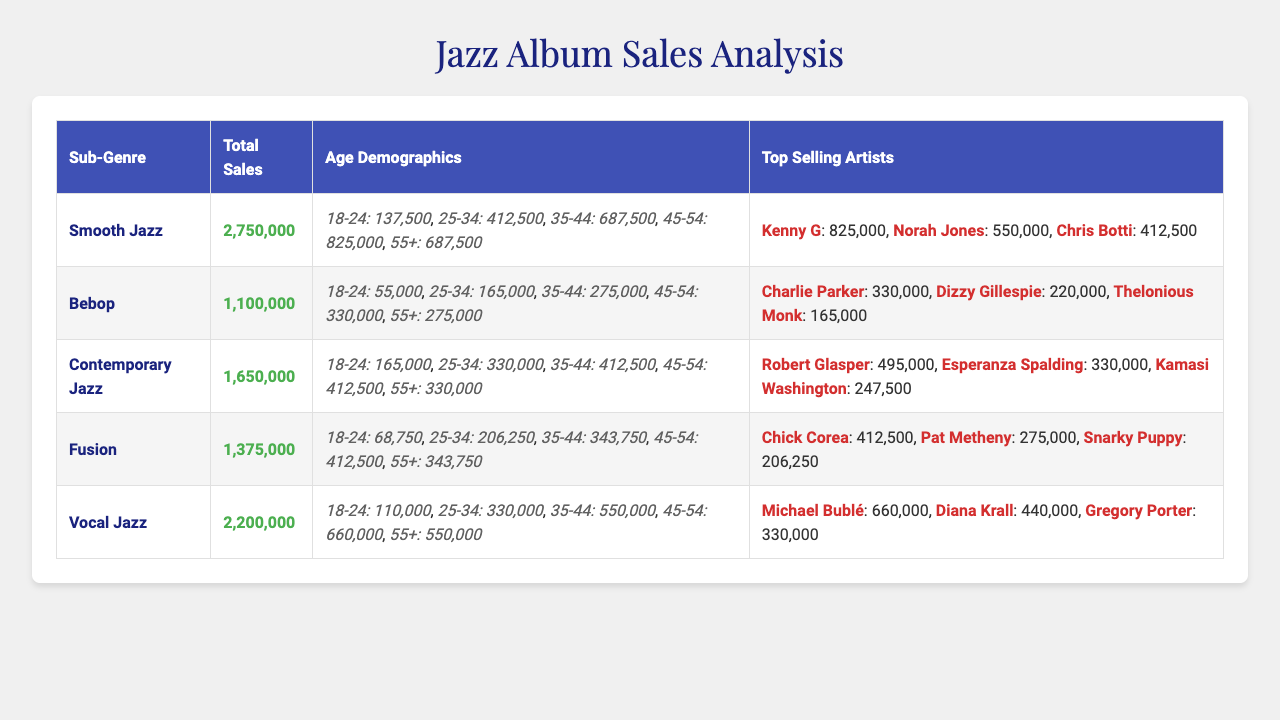What is the total sales for the Smooth Jazz sub-genre? The table indicates that the total sales for the Smooth Jazz sub-genre is 2,750,000.
Answer: 2,750,000 Which age demographic has the highest sales in Vocal Jazz? According to the table, the age demographic 45-54 has the highest sales in Vocal Jazz, with 660,000.
Answer: 45-54 What are the total sales for Bebop? The total sales for Bebop, as listed in the table, is 1,100,000.
Answer: 1,100,000 Which sub-genre has the lowest total sales? Comparing the total sales across all sub-genres, Bebop has the lowest total sales at 1,100,000.
Answer: Bebop What is the total sales of Contemporary Jazz for the age group 25-34? The total sales for the age group 25-34 in Contemporary Jazz is given as 330,000 in the table.
Answer: 330,000 What is the combined sales for the age demographic 55+ across all sub-genres? The breakdown shows: Smooth Jazz (687,500), Bebop (275,000), Contemporary Jazz (330,000), Fusion (343,750), and Vocal Jazz (550,000). Adding these gives 687,500 + 275,000 + 330,000 + 343,750 + 550,000 = 2,186,250.
Answer: 2,186,250 Which top-selling artist in Fusion has the highest sales? The table shows that Chick Corea is the top-selling artist in Fusion with sales of 412,500.
Answer: Chick Corea Does the age group 18-24 have more sales in Smooth Jazz or in Fusion? Looking at the numbers, Smooth Jazz has 137,500 sales for 18-24, while Fusion has 68,750. So, Smooth Jazz has higher sales in that age group.
Answer: Smooth Jazz Which sub-genre has higher sales, Vocal Jazz or Contemporary Jazz? Vocal Jazz has total sales of 2,200,000 while Contemporary Jazz has 1,650,000. Therefore, Vocal Jazz has higher sales.
Answer: Vocal Jazz What is the sum of total sales for the three top-selling artists in Contemporary Jazz? The top-selling artists in Contemporary Jazz have sales of 495,000 for Robert Glasper, 330,000 for Esperanza Spalding, and 247,500 for Kamasi Washington. Adding these gives 495,000 + 330,000 + 247,500 = 1,072,500.
Answer: 1,072,500 